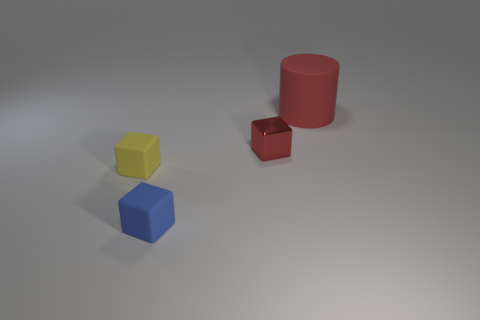Add 2 purple metal balls. How many objects exist? 6 Subtract all blocks. How many objects are left? 1 Subtract all small yellow things. Subtract all red things. How many objects are left? 1 Add 1 red metallic objects. How many red metallic objects are left? 2 Add 3 big cyan matte spheres. How many big cyan matte spheres exist? 3 Subtract 0 gray blocks. How many objects are left? 4 